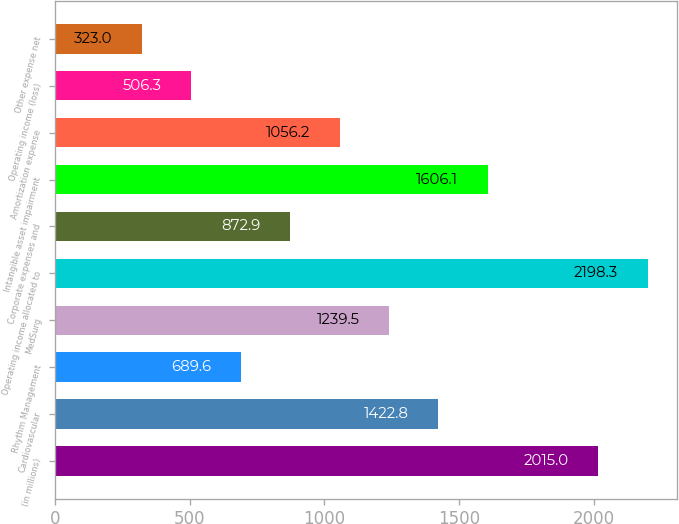<chart> <loc_0><loc_0><loc_500><loc_500><bar_chart><fcel>(in millions)<fcel>Cardiovascular<fcel>Rhythm Management<fcel>MedSurg<fcel>Operating income allocated to<fcel>Corporate expenses and<fcel>Intangible asset impairment<fcel>Amortization expense<fcel>Operating income (loss)<fcel>Other expense net<nl><fcel>2015<fcel>1422.8<fcel>689.6<fcel>1239.5<fcel>2198.3<fcel>872.9<fcel>1606.1<fcel>1056.2<fcel>506.3<fcel>323<nl></chart> 